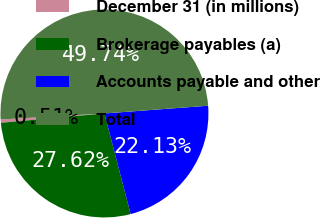<chart> <loc_0><loc_0><loc_500><loc_500><pie_chart><fcel>December 31 (in millions)<fcel>Brokerage payables (a)<fcel>Accounts payable and other<fcel>Total<nl><fcel>0.51%<fcel>27.62%<fcel>22.13%<fcel>49.74%<nl></chart> 